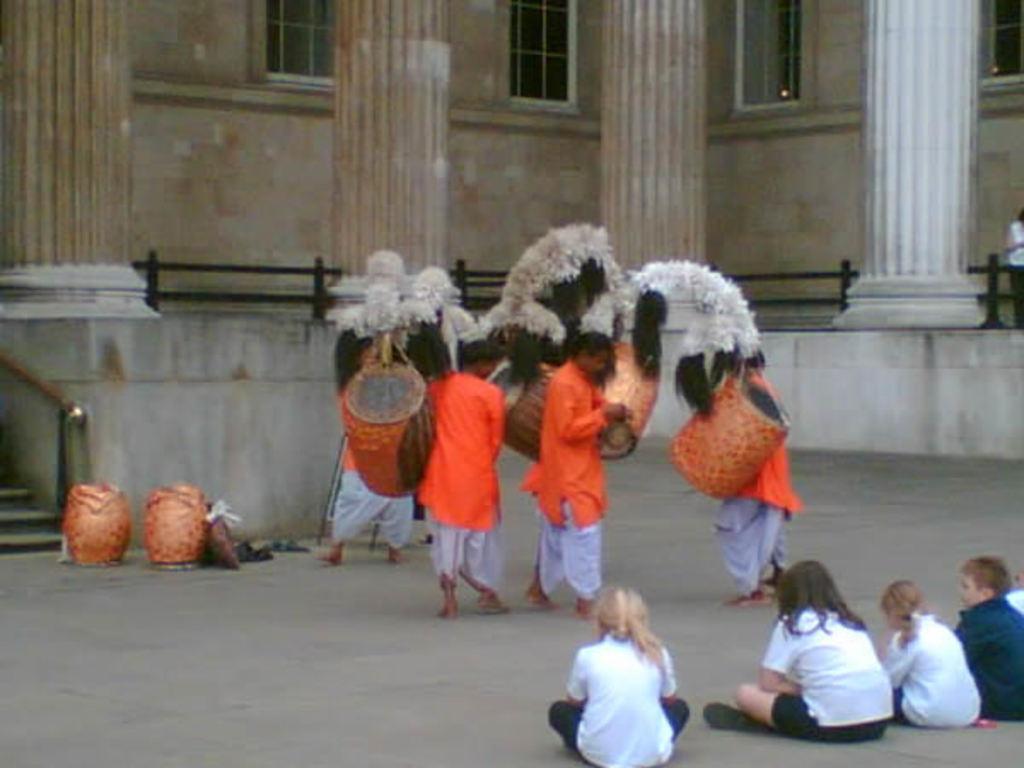In one or two sentences, can you explain what this image depicts? In this image, we can see few people. Few are standing and sitting on the floor. Here we can see some musical instruments. Background there is a house, pillars, glass windows, railing. Left side of the image, we can see stairs. Right side of the image, we can see a person is standing here. 